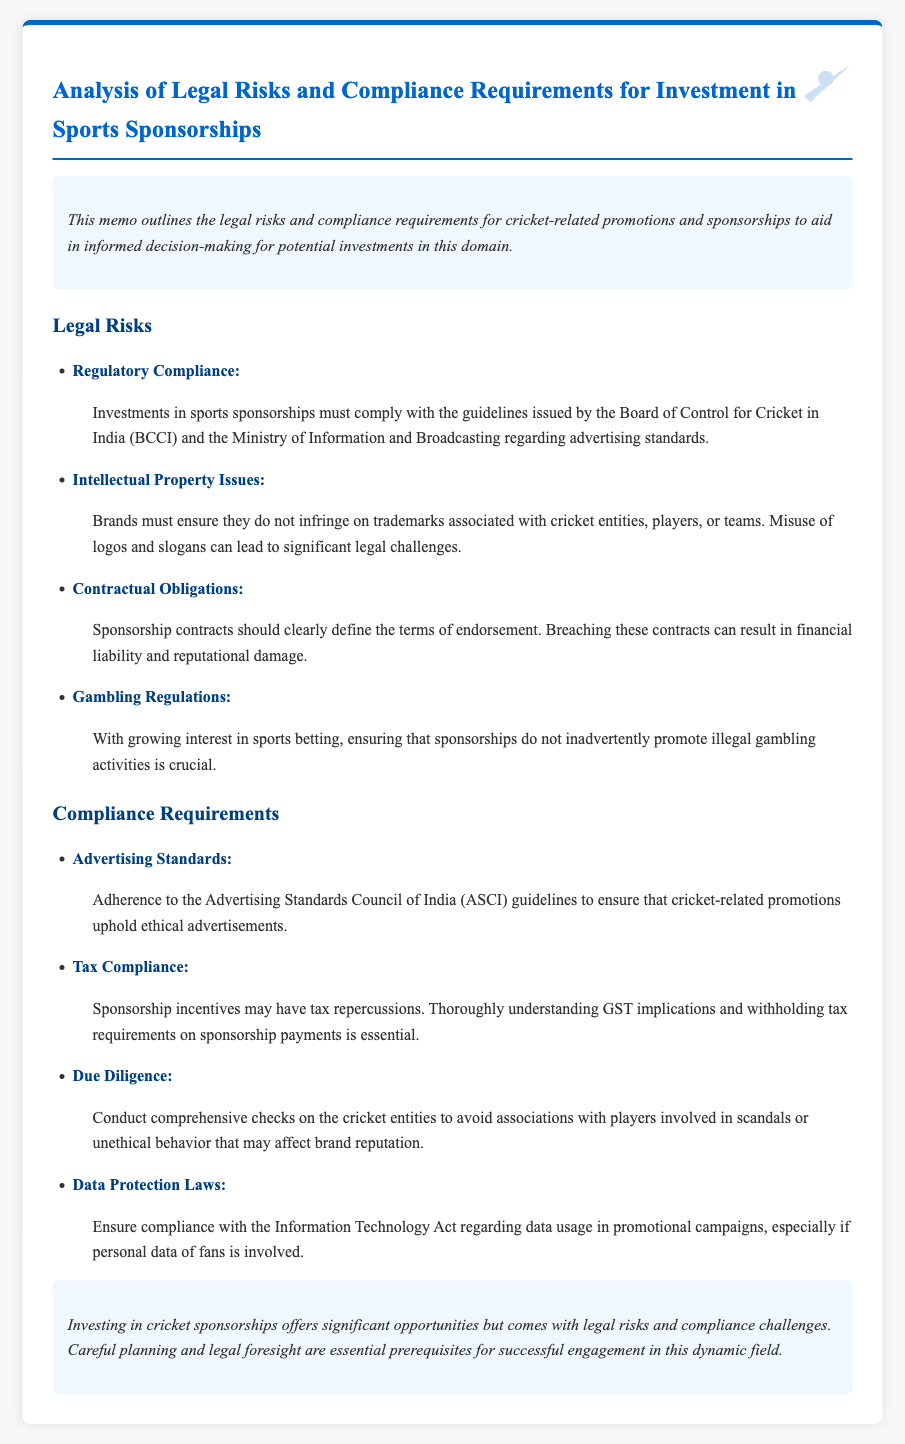What is the primary focus of this memo? The memo outlines the legal risks and compliance requirements for investment in sports sponsorships, specifically related to cricket-related promotions.
Answer: Legal risks and compliance requirements for cricket sponsorships Who should comply with BCCI guidelines? The investments in sports sponsorships must comply with the guidelines issued by the BCCI.
Answer: Brands What are the compliance requirements related to advertising? It requires adherence to the Advertising Standards Council of India guidelines to ensure ethical advertisements.
Answer: Advertising Standards What risk is associated with the misuse of logos? Misuse of logos can lead to significant legal challenges related to intellectual property issues.
Answer: Intellectual Property Issues Which tax consideration is mentioned in the memo? The memo states that sponsorship incentives may have tax repercussions, specifically mentioning GST implications and withholding tax requirements.
Answer: Tax Compliance How many legal risks are identified in the memo? The memo identifies four legal risks related to sports sponsorships.
Answer: Four What is emphasized for due diligence? Conduct comprehensive checks on cricket entities to avoid associations with players involved in scandals or unethical behavior.
Answer: Comprehensive checks What does the conclusion of the memo suggest about legal foresight? It states that careful planning and legal foresight are essential prerequisites for successful engagement in this dynamic field.
Answer: Essential prerequisites Which Act must be complied with regarding data usage? The Information Technology Act regarding data usage in promotional campaigns must be complied with.
Answer: Information Technology Act 